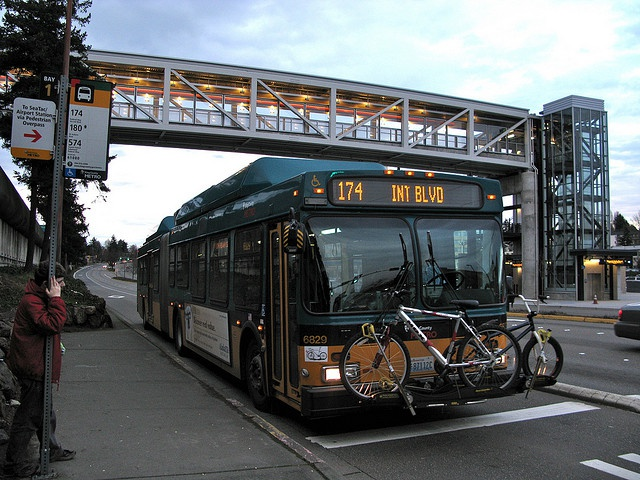Describe the objects in this image and their specific colors. I can see bus in black, gray, blue, and maroon tones, bicycle in black, gray, and maroon tones, people in black, maroon, gray, and darkgray tones, bicycle in black, gray, darkgray, and darkgreen tones, and car in black, gray, and darkgray tones in this image. 